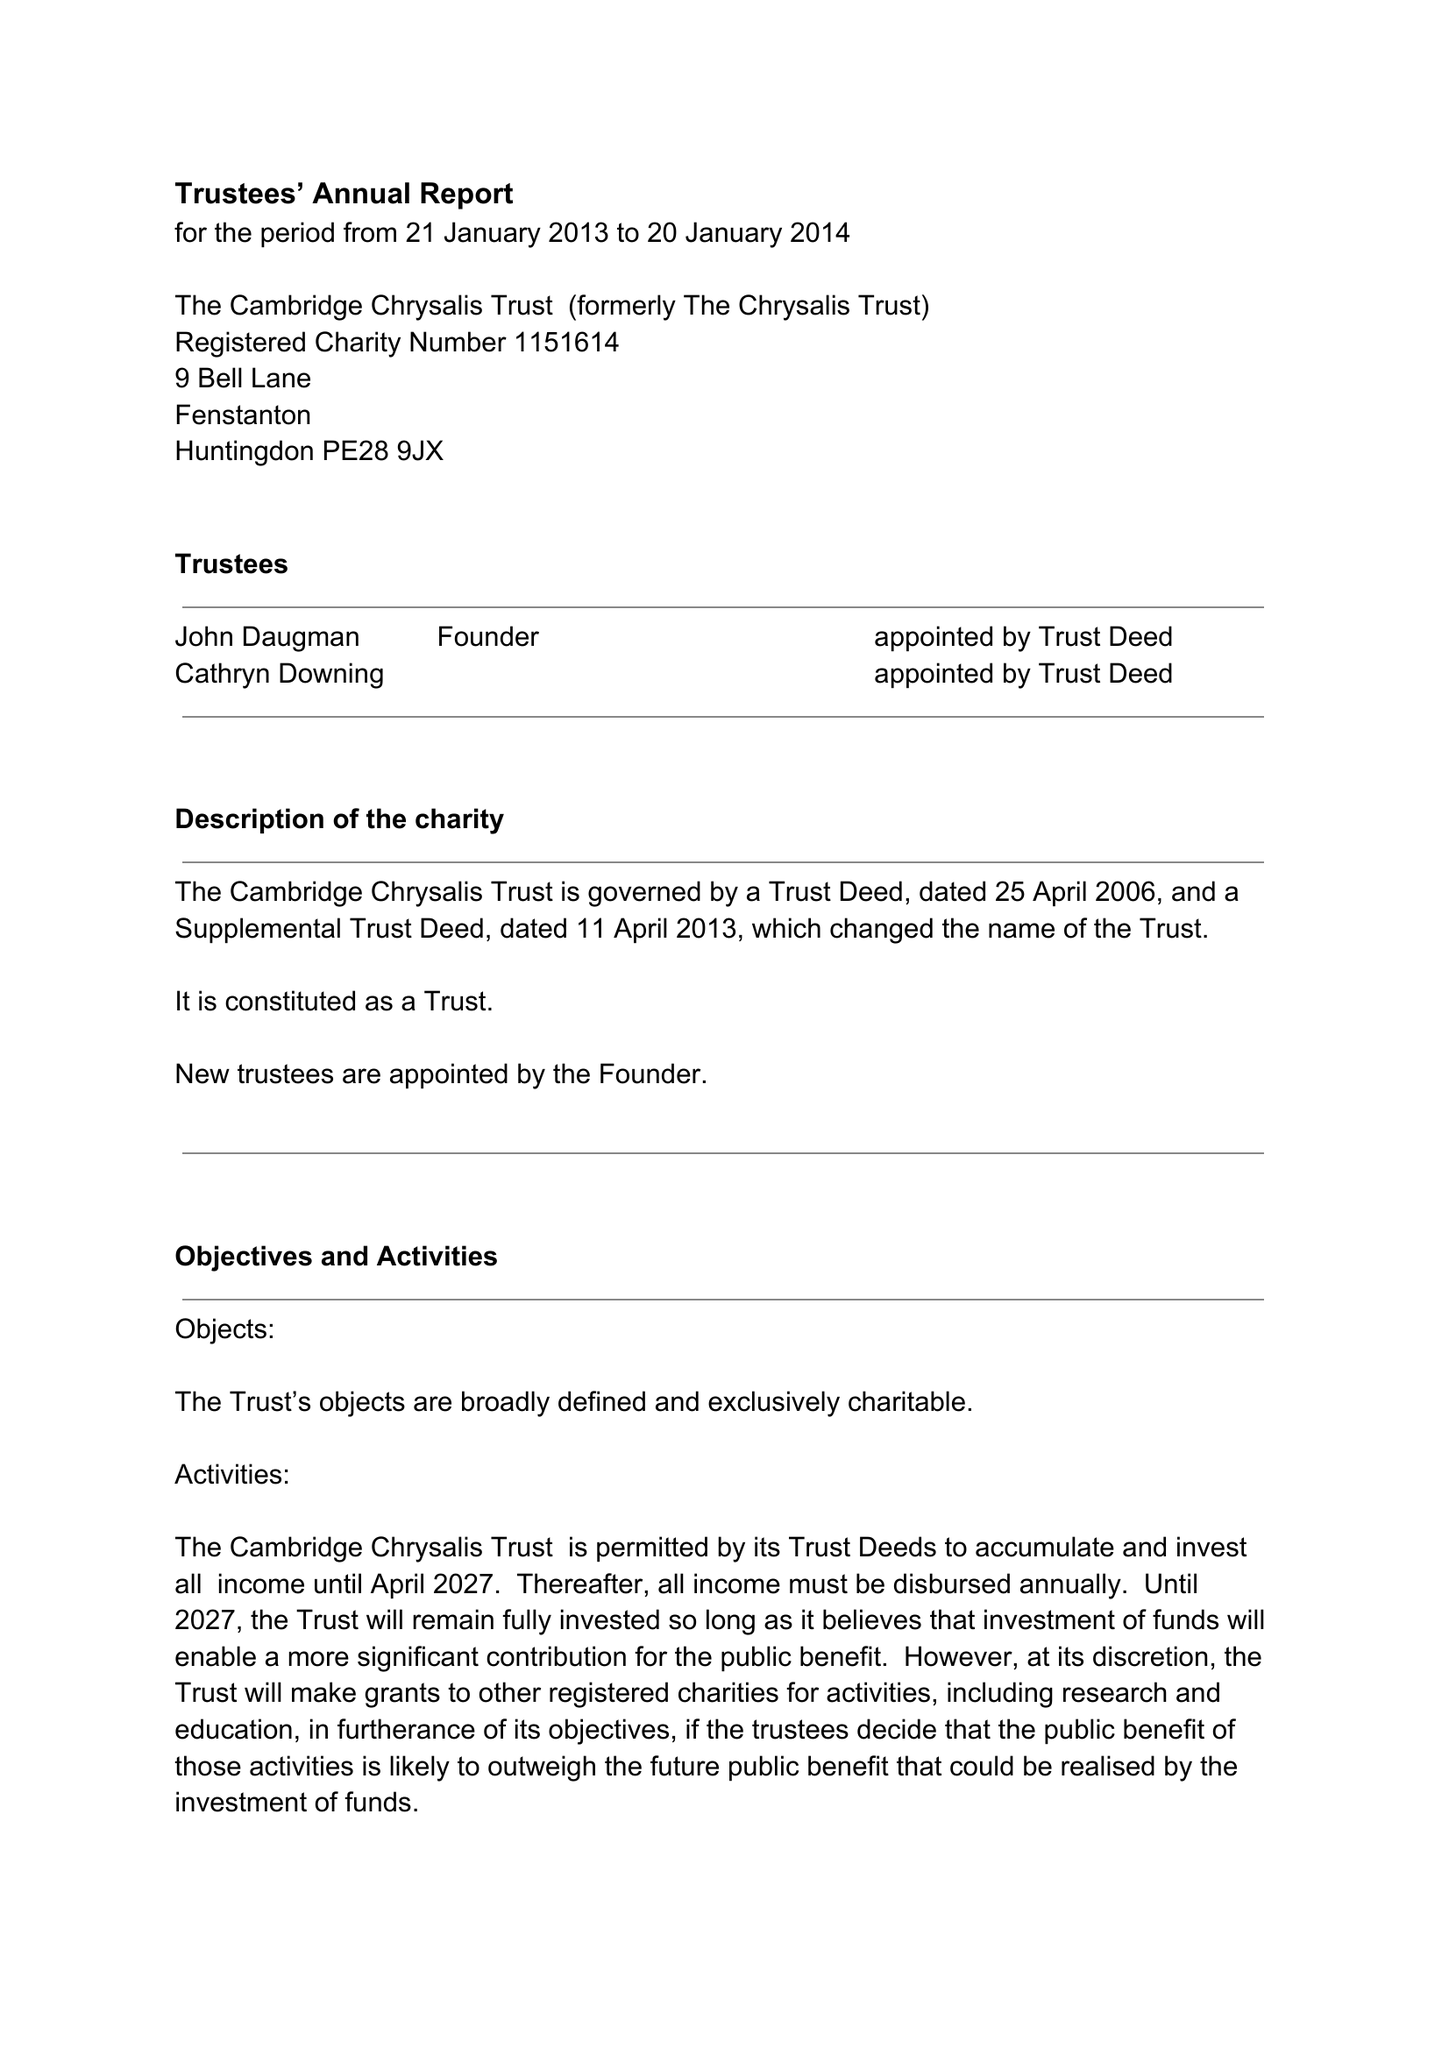What is the value for the spending_annually_in_british_pounds?
Answer the question using a single word or phrase. 133927.00 